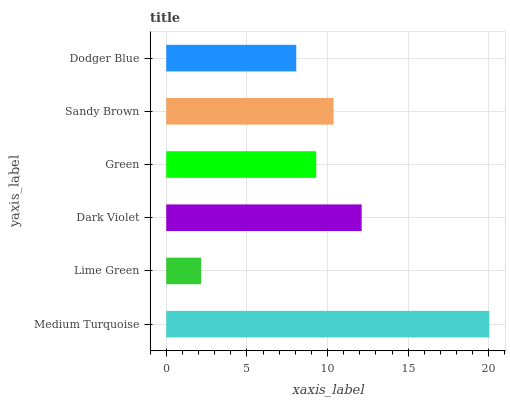Is Lime Green the minimum?
Answer yes or no. Yes. Is Medium Turquoise the maximum?
Answer yes or no. Yes. Is Dark Violet the minimum?
Answer yes or no. No. Is Dark Violet the maximum?
Answer yes or no. No. Is Dark Violet greater than Lime Green?
Answer yes or no. Yes. Is Lime Green less than Dark Violet?
Answer yes or no. Yes. Is Lime Green greater than Dark Violet?
Answer yes or no. No. Is Dark Violet less than Lime Green?
Answer yes or no. No. Is Sandy Brown the high median?
Answer yes or no. Yes. Is Green the low median?
Answer yes or no. Yes. Is Medium Turquoise the high median?
Answer yes or no. No. Is Dodger Blue the low median?
Answer yes or no. No. 